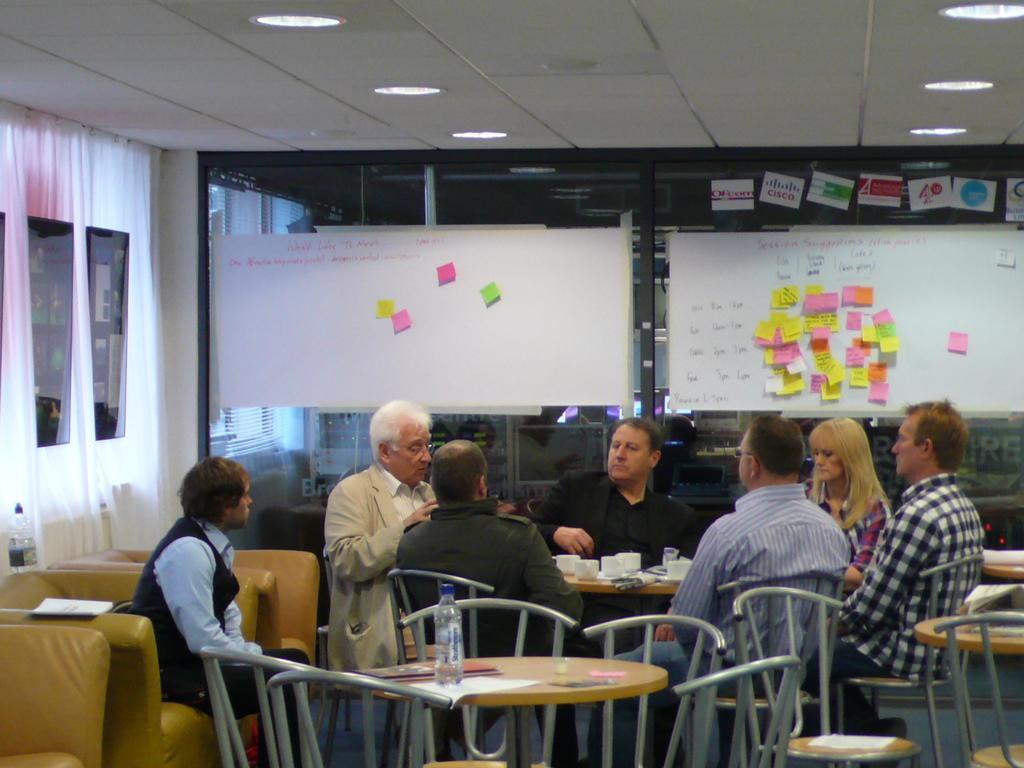How would you summarize this image in a sentence or two? This is a picture inside the room. There are group of people sitting around the table. There are cups, bottles, papers on the table. At the back there is a board, at the top there are lights and at the left there are curtains. 